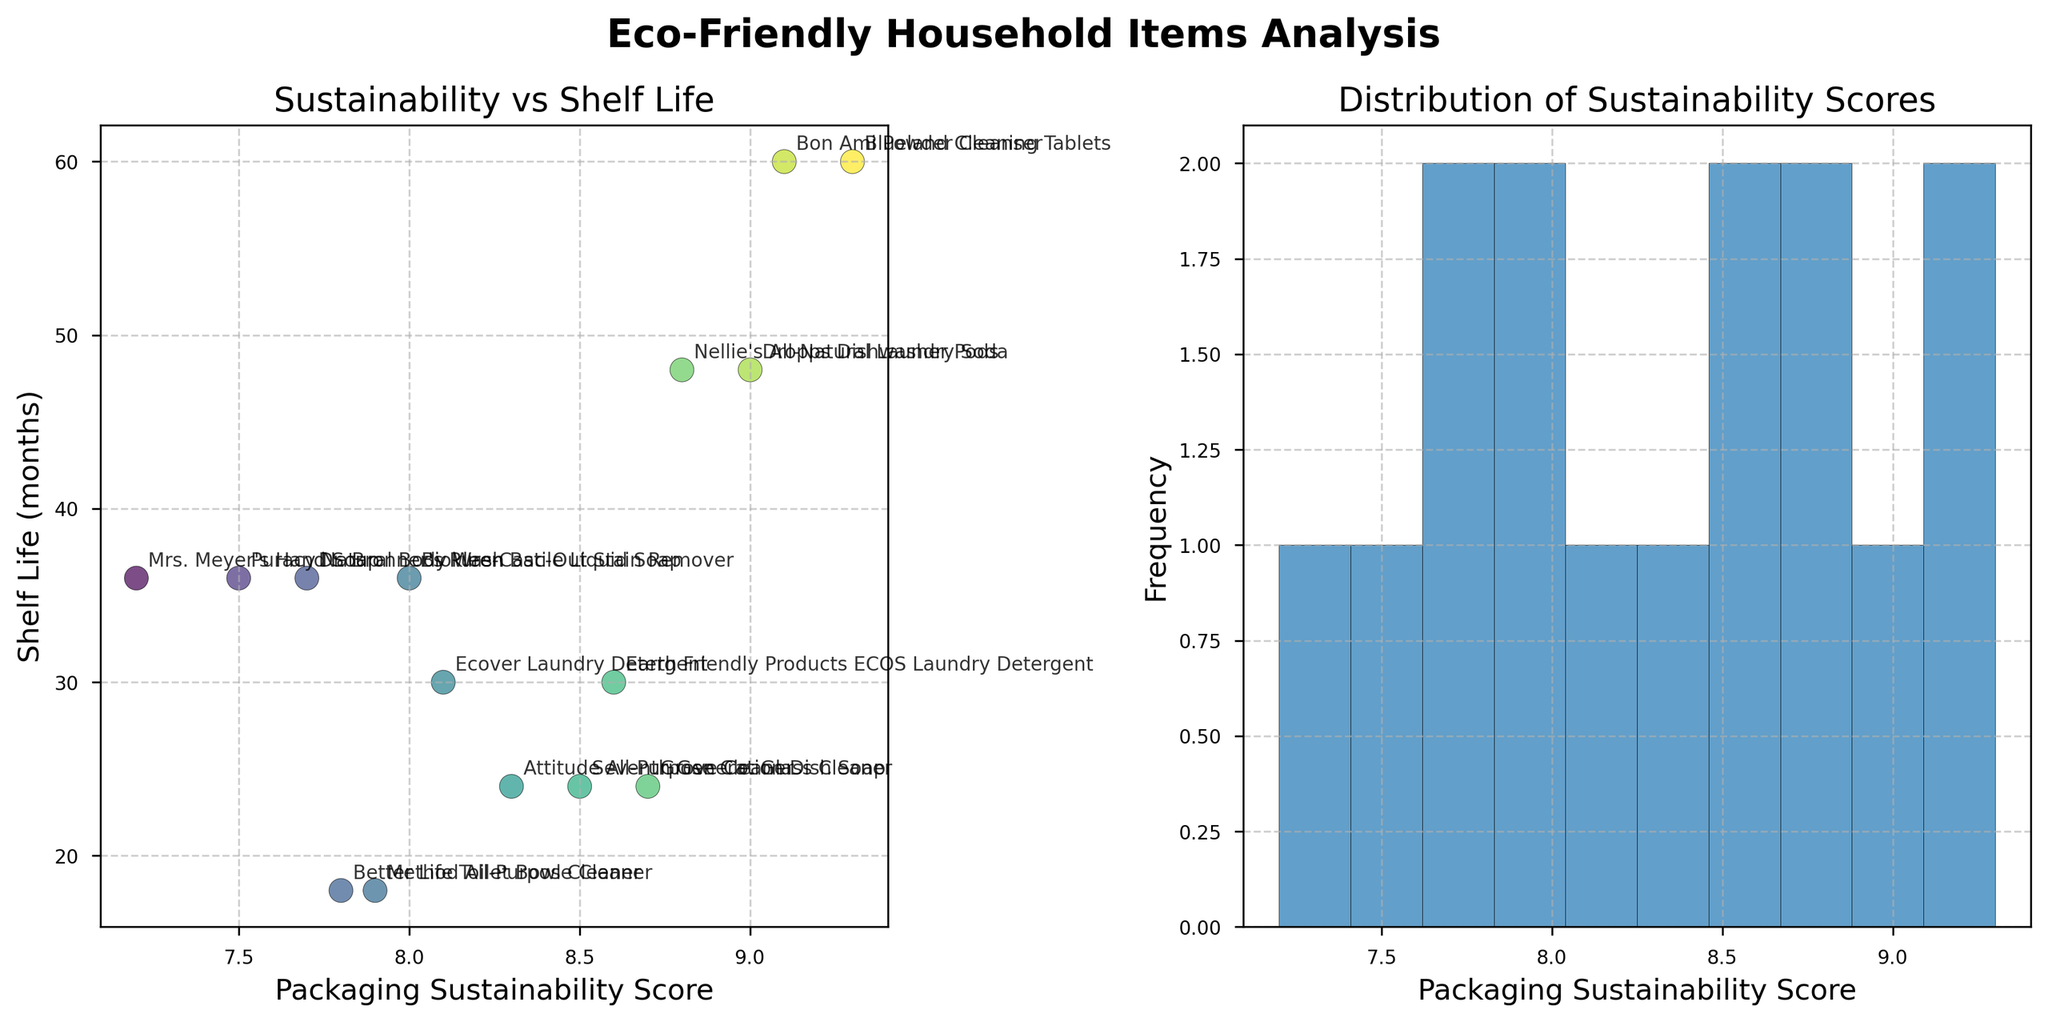What is the title of the figure? The title is located at the top of the figure and reads "Eco-Friendly Household Items Analysis".
Answer: Eco-Friendly Household Items Analysis How many data points are there in the scatter plot? You can count the number of dots present on the scatter plot.
Answer: 15 Which product has the highest Packaging Sustainability Score? Look for the rightmost point on the scatter plot, which indicates the highest Packaging Sustainability Score. The annotation next to this point is "Blueland Cleaning Tablets".
Answer: Blueland Cleaning Tablets Which product has the longest shelf life? Identify the highest point on the scatter plot, which represents the product with the longest shelf life. The annotation near this point indicates "Blueland Cleaning Tablets" and "Bon Ami Powder Cleanser".
Answer: Blueland Cleaning Tablets and Bon Ami Powder Cleanser What range of values does the histogram for Packaging Sustainability Score cover? Observe the x-axis of the histogram on the second subplot; it ranges from the lowest to the highest score visible.
Answer: 7.2 to 9.3 Is there any correlation between Packaging Sustainability Score and Shelf Life? Check the general trend in the scatter plot. If higher Sustainability Scores tend to align with longer Shelf Life, there is a positive correlation. In this case, the trend seems positive.
Answer: Yes, positive correlation Which product has a Packaging Sustainability Score of 7.5 and what is its Shelf Life? Locate the point on the scatter plot aligned with a score of 7.5 on the x-axis and read its corresponding y-axis value. The annotation next to this point indicates "Puracy Natural Body Wash".
Answer: Puracy Natural Body Wash How many products have a Packaging Sustainability Score greater than or equal to 8.0? Count the number of points to the right of the 8.0 mark on the x-axis of the scatter plot.
Answer: 10 Which product has the lowest Packaging Sustainability Score, and what is its Shelf Life? Find the leftmost point on the scatter plot indicating the lowest score. The annotation next to this point indicates "Mrs. Meyer's Hand Soap".
Answer: Mrs. Meyer's Hand Soap, 36 months What is the average Shelf Life for products with a Packaging Sustainability Score above 8.0? Identify the points on the scatter plot with scores above 8.0, read their Shelf Life values, and calculate the average of these values.
Answer: 37.8 months 